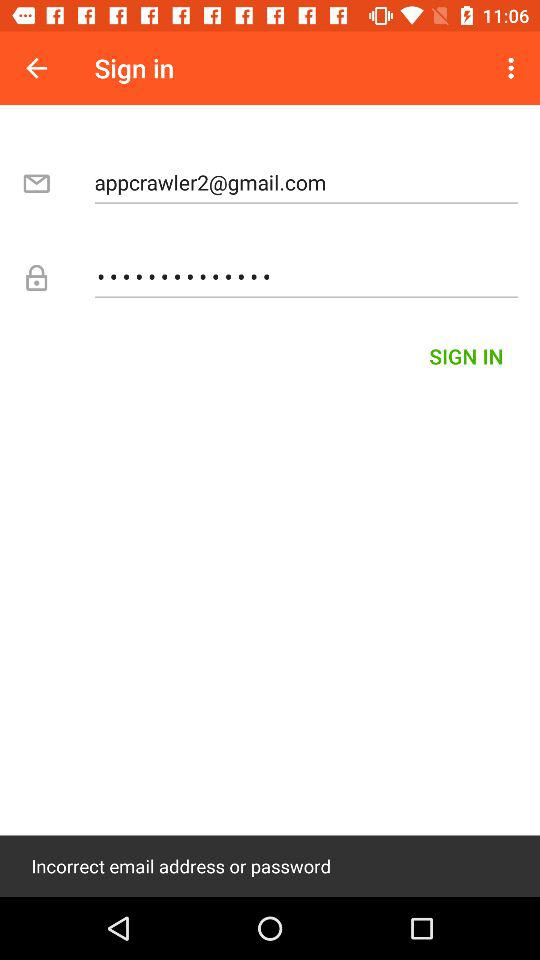How many fields are there for signing in?
Answer the question using a single word or phrase. 2 